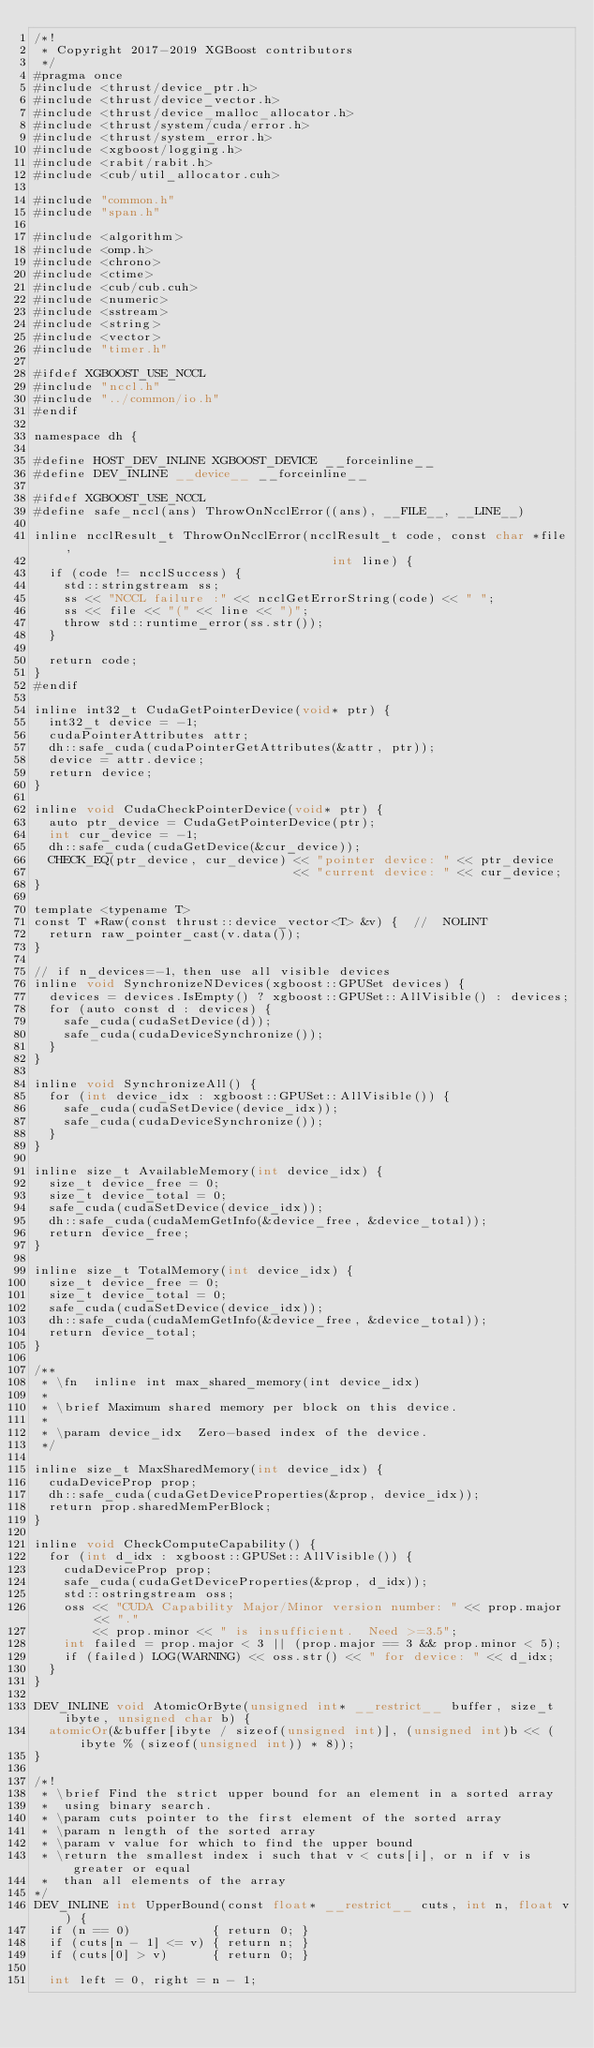<code> <loc_0><loc_0><loc_500><loc_500><_Cuda_>/*!
 * Copyright 2017-2019 XGBoost contributors
 */
#pragma once
#include <thrust/device_ptr.h>
#include <thrust/device_vector.h>
#include <thrust/device_malloc_allocator.h>
#include <thrust/system/cuda/error.h>
#include <thrust/system_error.h>
#include <xgboost/logging.h>
#include <rabit/rabit.h>
#include <cub/util_allocator.cuh>

#include "common.h"
#include "span.h"

#include <algorithm>
#include <omp.h>
#include <chrono>
#include <ctime>
#include <cub/cub.cuh>
#include <numeric>
#include <sstream>
#include <string>
#include <vector>
#include "timer.h"

#ifdef XGBOOST_USE_NCCL
#include "nccl.h"
#include "../common/io.h"
#endif

namespace dh {

#define HOST_DEV_INLINE XGBOOST_DEVICE __forceinline__
#define DEV_INLINE __device__ __forceinline__

#ifdef XGBOOST_USE_NCCL
#define safe_nccl(ans) ThrowOnNcclError((ans), __FILE__, __LINE__)

inline ncclResult_t ThrowOnNcclError(ncclResult_t code, const char *file,
                                        int line) {
  if (code != ncclSuccess) {
    std::stringstream ss;
    ss << "NCCL failure :" << ncclGetErrorString(code) << " ";
    ss << file << "(" << line << ")";
    throw std::runtime_error(ss.str());
  }

  return code;
}
#endif

inline int32_t CudaGetPointerDevice(void* ptr) {
  int32_t device = -1;
  cudaPointerAttributes attr;
  dh::safe_cuda(cudaPointerGetAttributes(&attr, ptr));
  device = attr.device;
  return device;
}

inline void CudaCheckPointerDevice(void* ptr) {
  auto ptr_device = CudaGetPointerDevice(ptr);
  int cur_device = -1;
  dh::safe_cuda(cudaGetDevice(&cur_device));
  CHECK_EQ(ptr_device, cur_device) << "pointer device: " << ptr_device
                                   << "current device: " << cur_device;
}

template <typename T>
const T *Raw(const thrust::device_vector<T> &v) {  //  NOLINT
  return raw_pointer_cast(v.data());
}

// if n_devices=-1, then use all visible devices
inline void SynchronizeNDevices(xgboost::GPUSet devices) {
  devices = devices.IsEmpty() ? xgboost::GPUSet::AllVisible() : devices;
  for (auto const d : devices) {
    safe_cuda(cudaSetDevice(d));
    safe_cuda(cudaDeviceSynchronize());
  }
}

inline void SynchronizeAll() {
  for (int device_idx : xgboost::GPUSet::AllVisible()) {
    safe_cuda(cudaSetDevice(device_idx));
    safe_cuda(cudaDeviceSynchronize());
  }
}

inline size_t AvailableMemory(int device_idx) {
  size_t device_free = 0;
  size_t device_total = 0;
  safe_cuda(cudaSetDevice(device_idx));
  dh::safe_cuda(cudaMemGetInfo(&device_free, &device_total));
  return device_free;
}

inline size_t TotalMemory(int device_idx) {
  size_t device_free = 0;
  size_t device_total = 0;
  safe_cuda(cudaSetDevice(device_idx));
  dh::safe_cuda(cudaMemGetInfo(&device_free, &device_total));
  return device_total;
}

/**
 * \fn  inline int max_shared_memory(int device_idx)
 *
 * \brief Maximum shared memory per block on this device.
 *
 * \param device_idx  Zero-based index of the device.
 */

inline size_t MaxSharedMemory(int device_idx) {
  cudaDeviceProp prop;
  dh::safe_cuda(cudaGetDeviceProperties(&prop, device_idx));
  return prop.sharedMemPerBlock;
}

inline void CheckComputeCapability() {
  for (int d_idx : xgboost::GPUSet::AllVisible()) {
    cudaDeviceProp prop;
    safe_cuda(cudaGetDeviceProperties(&prop, d_idx));
    std::ostringstream oss;
    oss << "CUDA Capability Major/Minor version number: " << prop.major << "."
        << prop.minor << " is insufficient.  Need >=3.5";
    int failed = prop.major < 3 || (prop.major == 3 && prop.minor < 5);
    if (failed) LOG(WARNING) << oss.str() << " for device: " << d_idx;
  }
}

DEV_INLINE void AtomicOrByte(unsigned int* __restrict__ buffer, size_t ibyte, unsigned char b) {
  atomicOr(&buffer[ibyte / sizeof(unsigned int)], (unsigned int)b << (ibyte % (sizeof(unsigned int)) * 8));
}

/*!
 * \brief Find the strict upper bound for an element in a sorted array
 *  using binary search.
 * \param cuts pointer to the first element of the sorted array
 * \param n length of the sorted array
 * \param v value for which to find the upper bound
 * \return the smallest index i such that v < cuts[i], or n if v is greater or equal
 *  than all elements of the array
*/
DEV_INLINE int UpperBound(const float* __restrict__ cuts, int n, float v) {
  if (n == 0)           { return 0; }
  if (cuts[n - 1] <= v) { return n; }
  if (cuts[0] > v)      { return 0; }

  int left = 0, right = n - 1;</code> 